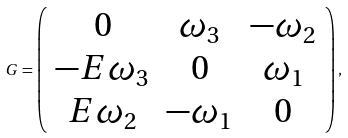Convert formula to latex. <formula><loc_0><loc_0><loc_500><loc_500>G = \left ( \begin{array} { c c c } 0 & \omega _ { 3 } & - \omega _ { 2 } \\ - E \omega _ { 3 } & 0 & \omega _ { 1 } \\ E \omega _ { 2 } & - \omega _ { 1 } & 0 \end{array} \right ) ,</formula> 